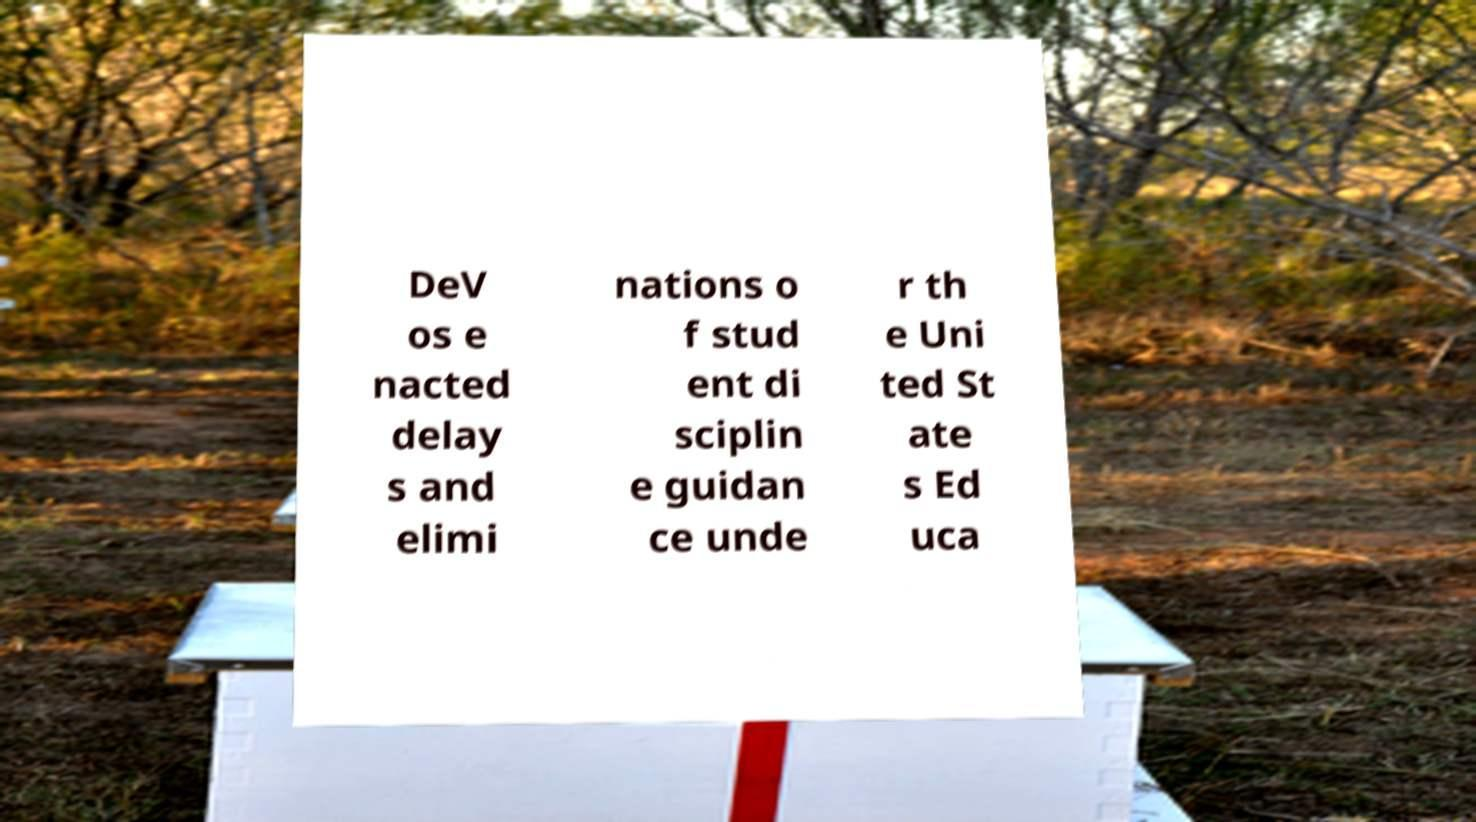Could you extract and type out the text from this image? DeV os e nacted delay s and elimi nations o f stud ent di sciplin e guidan ce unde r th e Uni ted St ate s Ed uca 